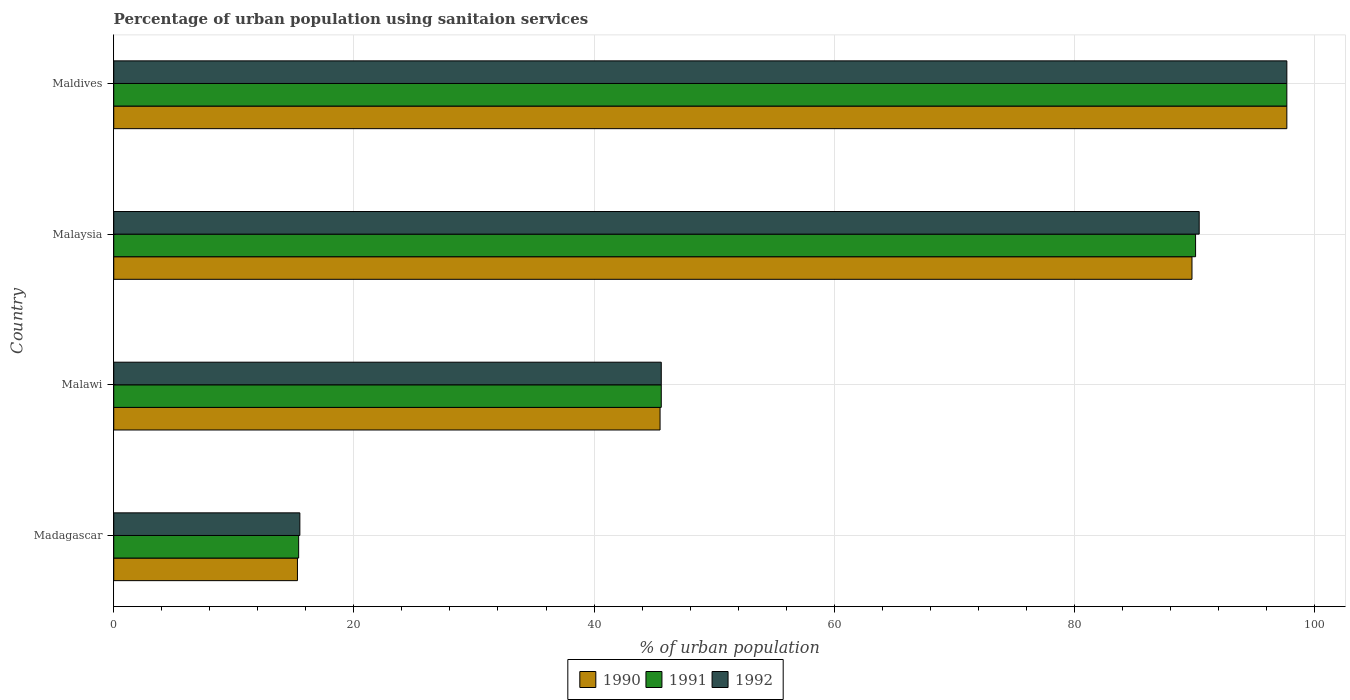What is the label of the 1st group of bars from the top?
Your answer should be very brief. Maldives. In how many cases, is the number of bars for a given country not equal to the number of legend labels?
Your answer should be compact. 0. What is the percentage of urban population using sanitaion services in 1991 in Malawi?
Offer a very short reply. 45.6. Across all countries, what is the maximum percentage of urban population using sanitaion services in 1992?
Offer a terse response. 97.7. In which country was the percentage of urban population using sanitaion services in 1991 maximum?
Offer a terse response. Maldives. In which country was the percentage of urban population using sanitaion services in 1992 minimum?
Provide a succinct answer. Madagascar. What is the total percentage of urban population using sanitaion services in 1992 in the graph?
Provide a short and direct response. 249.2. What is the difference between the percentage of urban population using sanitaion services in 1990 in Malaysia and that in Maldives?
Make the answer very short. -7.9. What is the difference between the percentage of urban population using sanitaion services in 1991 in Malawi and the percentage of urban population using sanitaion services in 1990 in Malaysia?
Keep it short and to the point. -44.2. What is the average percentage of urban population using sanitaion services in 1991 per country?
Ensure brevity in your answer.  62.2. What is the difference between the percentage of urban population using sanitaion services in 1991 and percentage of urban population using sanitaion services in 1992 in Maldives?
Make the answer very short. 0. In how many countries, is the percentage of urban population using sanitaion services in 1991 greater than 84 %?
Offer a very short reply. 2. What is the ratio of the percentage of urban population using sanitaion services in 1991 in Madagascar to that in Maldives?
Provide a succinct answer. 0.16. Is the percentage of urban population using sanitaion services in 1991 in Malawi less than that in Maldives?
Your response must be concise. Yes. Is the difference between the percentage of urban population using sanitaion services in 1991 in Madagascar and Maldives greater than the difference between the percentage of urban population using sanitaion services in 1992 in Madagascar and Maldives?
Give a very brief answer. No. What is the difference between the highest and the second highest percentage of urban population using sanitaion services in 1990?
Make the answer very short. 7.9. What is the difference between the highest and the lowest percentage of urban population using sanitaion services in 1992?
Provide a succinct answer. 82.2. In how many countries, is the percentage of urban population using sanitaion services in 1991 greater than the average percentage of urban population using sanitaion services in 1991 taken over all countries?
Your answer should be compact. 2. Are all the bars in the graph horizontal?
Provide a short and direct response. Yes. How many countries are there in the graph?
Offer a terse response. 4. What is the difference between two consecutive major ticks on the X-axis?
Ensure brevity in your answer.  20. Are the values on the major ticks of X-axis written in scientific E-notation?
Offer a very short reply. No. Does the graph contain any zero values?
Your response must be concise. No. Does the graph contain grids?
Your response must be concise. Yes. How many legend labels are there?
Make the answer very short. 3. How are the legend labels stacked?
Your answer should be compact. Horizontal. What is the title of the graph?
Make the answer very short. Percentage of urban population using sanitaion services. What is the label or title of the X-axis?
Provide a short and direct response. % of urban population. What is the label or title of the Y-axis?
Ensure brevity in your answer.  Country. What is the % of urban population of 1990 in Madagascar?
Provide a succinct answer. 15.3. What is the % of urban population in 1991 in Madagascar?
Your answer should be very brief. 15.4. What is the % of urban population in 1992 in Madagascar?
Your answer should be compact. 15.5. What is the % of urban population in 1990 in Malawi?
Ensure brevity in your answer.  45.5. What is the % of urban population in 1991 in Malawi?
Your answer should be compact. 45.6. What is the % of urban population of 1992 in Malawi?
Make the answer very short. 45.6. What is the % of urban population in 1990 in Malaysia?
Offer a very short reply. 89.8. What is the % of urban population of 1991 in Malaysia?
Your answer should be very brief. 90.1. What is the % of urban population in 1992 in Malaysia?
Your response must be concise. 90.4. What is the % of urban population of 1990 in Maldives?
Provide a short and direct response. 97.7. What is the % of urban population in 1991 in Maldives?
Offer a very short reply. 97.7. What is the % of urban population of 1992 in Maldives?
Provide a short and direct response. 97.7. Across all countries, what is the maximum % of urban population in 1990?
Give a very brief answer. 97.7. Across all countries, what is the maximum % of urban population of 1991?
Your answer should be compact. 97.7. Across all countries, what is the maximum % of urban population of 1992?
Provide a succinct answer. 97.7. Across all countries, what is the minimum % of urban population of 1990?
Your response must be concise. 15.3. Across all countries, what is the minimum % of urban population in 1991?
Your answer should be very brief. 15.4. What is the total % of urban population of 1990 in the graph?
Ensure brevity in your answer.  248.3. What is the total % of urban population of 1991 in the graph?
Your answer should be very brief. 248.8. What is the total % of urban population of 1992 in the graph?
Give a very brief answer. 249.2. What is the difference between the % of urban population in 1990 in Madagascar and that in Malawi?
Make the answer very short. -30.2. What is the difference between the % of urban population of 1991 in Madagascar and that in Malawi?
Give a very brief answer. -30.2. What is the difference between the % of urban population of 1992 in Madagascar and that in Malawi?
Your answer should be very brief. -30.1. What is the difference between the % of urban population in 1990 in Madagascar and that in Malaysia?
Your answer should be compact. -74.5. What is the difference between the % of urban population in 1991 in Madagascar and that in Malaysia?
Provide a short and direct response. -74.7. What is the difference between the % of urban population in 1992 in Madagascar and that in Malaysia?
Ensure brevity in your answer.  -74.9. What is the difference between the % of urban population in 1990 in Madagascar and that in Maldives?
Your response must be concise. -82.4. What is the difference between the % of urban population of 1991 in Madagascar and that in Maldives?
Provide a short and direct response. -82.3. What is the difference between the % of urban population of 1992 in Madagascar and that in Maldives?
Make the answer very short. -82.2. What is the difference between the % of urban population of 1990 in Malawi and that in Malaysia?
Offer a very short reply. -44.3. What is the difference between the % of urban population of 1991 in Malawi and that in Malaysia?
Offer a very short reply. -44.5. What is the difference between the % of urban population of 1992 in Malawi and that in Malaysia?
Offer a very short reply. -44.8. What is the difference between the % of urban population in 1990 in Malawi and that in Maldives?
Your answer should be very brief. -52.2. What is the difference between the % of urban population of 1991 in Malawi and that in Maldives?
Make the answer very short. -52.1. What is the difference between the % of urban population in 1992 in Malawi and that in Maldives?
Provide a succinct answer. -52.1. What is the difference between the % of urban population of 1991 in Malaysia and that in Maldives?
Provide a succinct answer. -7.6. What is the difference between the % of urban population of 1992 in Malaysia and that in Maldives?
Your answer should be very brief. -7.3. What is the difference between the % of urban population in 1990 in Madagascar and the % of urban population in 1991 in Malawi?
Provide a short and direct response. -30.3. What is the difference between the % of urban population of 1990 in Madagascar and the % of urban population of 1992 in Malawi?
Make the answer very short. -30.3. What is the difference between the % of urban population of 1991 in Madagascar and the % of urban population of 1992 in Malawi?
Your answer should be very brief. -30.2. What is the difference between the % of urban population of 1990 in Madagascar and the % of urban population of 1991 in Malaysia?
Offer a terse response. -74.8. What is the difference between the % of urban population in 1990 in Madagascar and the % of urban population in 1992 in Malaysia?
Make the answer very short. -75.1. What is the difference between the % of urban population of 1991 in Madagascar and the % of urban population of 1992 in Malaysia?
Provide a short and direct response. -75. What is the difference between the % of urban population in 1990 in Madagascar and the % of urban population in 1991 in Maldives?
Your response must be concise. -82.4. What is the difference between the % of urban population of 1990 in Madagascar and the % of urban population of 1992 in Maldives?
Ensure brevity in your answer.  -82.4. What is the difference between the % of urban population of 1991 in Madagascar and the % of urban population of 1992 in Maldives?
Make the answer very short. -82.3. What is the difference between the % of urban population of 1990 in Malawi and the % of urban population of 1991 in Malaysia?
Ensure brevity in your answer.  -44.6. What is the difference between the % of urban population of 1990 in Malawi and the % of urban population of 1992 in Malaysia?
Make the answer very short. -44.9. What is the difference between the % of urban population of 1991 in Malawi and the % of urban population of 1992 in Malaysia?
Provide a short and direct response. -44.8. What is the difference between the % of urban population in 1990 in Malawi and the % of urban population in 1991 in Maldives?
Ensure brevity in your answer.  -52.2. What is the difference between the % of urban population in 1990 in Malawi and the % of urban population in 1992 in Maldives?
Provide a short and direct response. -52.2. What is the difference between the % of urban population in 1991 in Malawi and the % of urban population in 1992 in Maldives?
Give a very brief answer. -52.1. What is the difference between the % of urban population of 1990 in Malaysia and the % of urban population of 1991 in Maldives?
Give a very brief answer. -7.9. What is the average % of urban population in 1990 per country?
Your answer should be compact. 62.08. What is the average % of urban population in 1991 per country?
Provide a succinct answer. 62.2. What is the average % of urban population in 1992 per country?
Offer a very short reply. 62.3. What is the difference between the % of urban population in 1990 and % of urban population in 1991 in Madagascar?
Your answer should be compact. -0.1. What is the difference between the % of urban population of 1990 and % of urban population of 1992 in Madagascar?
Your answer should be very brief. -0.2. What is the difference between the % of urban population of 1990 and % of urban population of 1991 in Malawi?
Your answer should be very brief. -0.1. What is the difference between the % of urban population of 1990 and % of urban population of 1992 in Malawi?
Give a very brief answer. -0.1. What is the difference between the % of urban population of 1991 and % of urban population of 1992 in Malawi?
Your answer should be very brief. 0. What is the difference between the % of urban population of 1990 and % of urban population of 1991 in Malaysia?
Keep it short and to the point. -0.3. What is the difference between the % of urban population in 1991 and % of urban population in 1992 in Malaysia?
Keep it short and to the point. -0.3. What is the ratio of the % of urban population of 1990 in Madagascar to that in Malawi?
Keep it short and to the point. 0.34. What is the ratio of the % of urban population in 1991 in Madagascar to that in Malawi?
Your answer should be compact. 0.34. What is the ratio of the % of urban population in 1992 in Madagascar to that in Malawi?
Provide a succinct answer. 0.34. What is the ratio of the % of urban population of 1990 in Madagascar to that in Malaysia?
Keep it short and to the point. 0.17. What is the ratio of the % of urban population of 1991 in Madagascar to that in Malaysia?
Provide a short and direct response. 0.17. What is the ratio of the % of urban population in 1992 in Madagascar to that in Malaysia?
Provide a succinct answer. 0.17. What is the ratio of the % of urban population of 1990 in Madagascar to that in Maldives?
Offer a terse response. 0.16. What is the ratio of the % of urban population in 1991 in Madagascar to that in Maldives?
Provide a succinct answer. 0.16. What is the ratio of the % of urban population of 1992 in Madagascar to that in Maldives?
Your answer should be very brief. 0.16. What is the ratio of the % of urban population of 1990 in Malawi to that in Malaysia?
Your answer should be very brief. 0.51. What is the ratio of the % of urban population in 1991 in Malawi to that in Malaysia?
Provide a succinct answer. 0.51. What is the ratio of the % of urban population of 1992 in Malawi to that in Malaysia?
Provide a succinct answer. 0.5. What is the ratio of the % of urban population of 1990 in Malawi to that in Maldives?
Your response must be concise. 0.47. What is the ratio of the % of urban population in 1991 in Malawi to that in Maldives?
Your answer should be very brief. 0.47. What is the ratio of the % of urban population in 1992 in Malawi to that in Maldives?
Offer a terse response. 0.47. What is the ratio of the % of urban population in 1990 in Malaysia to that in Maldives?
Offer a terse response. 0.92. What is the ratio of the % of urban population of 1991 in Malaysia to that in Maldives?
Make the answer very short. 0.92. What is the ratio of the % of urban population of 1992 in Malaysia to that in Maldives?
Your answer should be compact. 0.93. What is the difference between the highest and the second highest % of urban population in 1990?
Your answer should be compact. 7.9. What is the difference between the highest and the second highest % of urban population in 1991?
Ensure brevity in your answer.  7.6. What is the difference between the highest and the lowest % of urban population in 1990?
Make the answer very short. 82.4. What is the difference between the highest and the lowest % of urban population in 1991?
Keep it short and to the point. 82.3. What is the difference between the highest and the lowest % of urban population of 1992?
Provide a succinct answer. 82.2. 